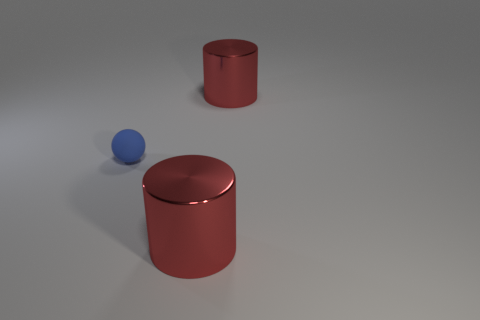Add 1 tiny red metal balls. How many objects exist? 4 Subtract all balls. How many objects are left? 2 Subtract all big cylinders. Subtract all blue rubber things. How many objects are left? 0 Add 2 metallic cylinders. How many metallic cylinders are left? 4 Add 2 big yellow shiny blocks. How many big yellow shiny blocks exist? 2 Subtract 0 yellow spheres. How many objects are left? 3 